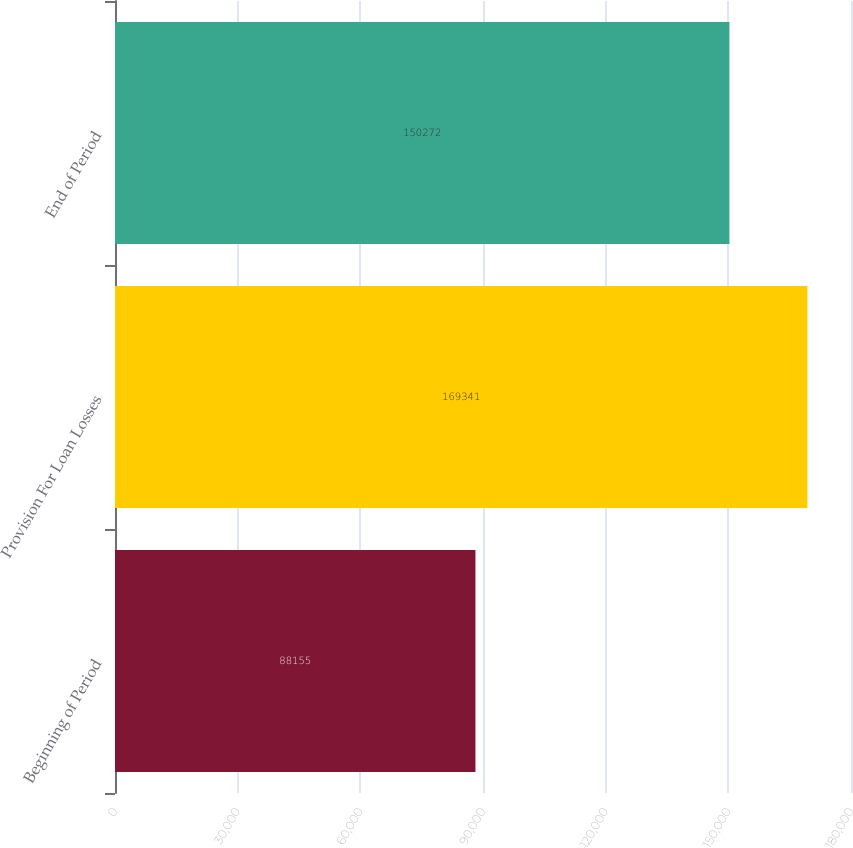Convert chart. <chart><loc_0><loc_0><loc_500><loc_500><bar_chart><fcel>Beginning of Period<fcel>Provision For Loan Losses<fcel>End of Period<nl><fcel>88155<fcel>169341<fcel>150272<nl></chart> 